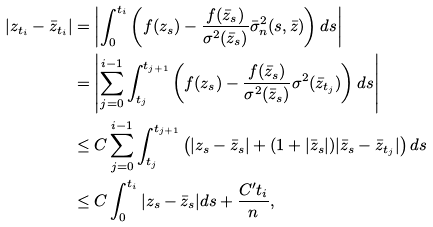Convert formula to latex. <formula><loc_0><loc_0><loc_500><loc_500>| z _ { t _ { i } } - \bar { z } _ { t _ { i } } | & = \left | \int _ { 0 } ^ { t _ { i } } \left ( f ( z _ { s } ) - \frac { f ( \bar { z } _ { s } ) } { \sigma ^ { 2 } ( \bar { z } _ { s } ) } \bar { \sigma } _ { n } ^ { 2 } ( s , \bar { z } ) \right ) d s \right | \\ & = \left | \sum _ { j = 0 } ^ { i - 1 } \int _ { t _ { j } } ^ { t _ { j + 1 } } \left ( f ( z _ { s } ) - \frac { f ( \bar { z } _ { s } ) } { \sigma ^ { 2 } ( \bar { z } _ { s } ) } \sigma ^ { 2 } ( \bar { z } _ { t _ { j } } ) \right ) d s \right | \\ & \leq C \sum _ { j = 0 } ^ { i - 1 } \int _ { t _ { j } } ^ { t _ { j + 1 } } \left ( | z _ { s } - \bar { z } _ { s } | + ( 1 + | \bar { z } _ { s } | ) | \bar { z } _ { s } - \bar { z } _ { t _ { j } } | \right ) d s \\ & \leq C \int _ { 0 } ^ { t _ { i } } | z _ { s } - \bar { z } _ { s } | d s + \frac { C ^ { \prime } t _ { i } } { n } ,</formula> 